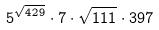<formula> <loc_0><loc_0><loc_500><loc_500>5 ^ { \sqrt { 4 2 9 } } \cdot 7 \cdot \sqrt { 1 1 1 } \cdot 3 9 7</formula> 